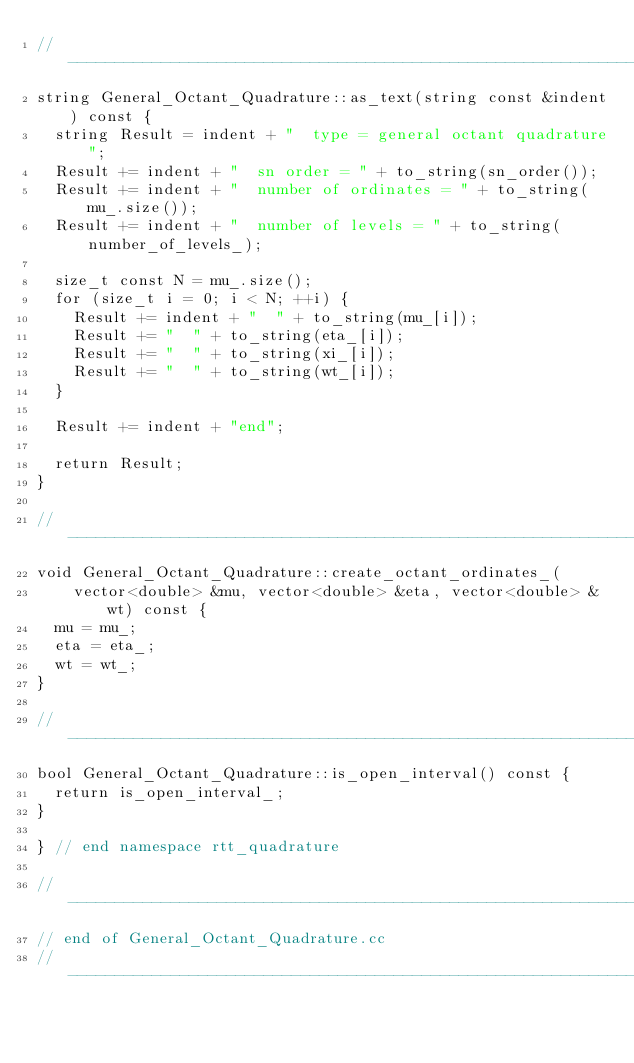Convert code to text. <code><loc_0><loc_0><loc_500><loc_500><_C++_>//---------------------------------------------------------------------------//
string General_Octant_Quadrature::as_text(string const &indent) const {
  string Result = indent + "  type = general octant quadrature";
  Result += indent + "  sn order = " + to_string(sn_order());
  Result += indent + "  number of ordinates = " + to_string(mu_.size());
  Result += indent + "  number of levels = " + to_string(number_of_levels_);

  size_t const N = mu_.size();
  for (size_t i = 0; i < N; ++i) {
    Result += indent + "  " + to_string(mu_[i]);
    Result += "  " + to_string(eta_[i]);
    Result += "  " + to_string(xi_[i]);
    Result += "  " + to_string(wt_[i]);
  }

  Result += indent + "end";

  return Result;
}

//---------------------------------------------------------------------------//
void General_Octant_Quadrature::create_octant_ordinates_(
    vector<double> &mu, vector<double> &eta, vector<double> &wt) const {
  mu = mu_;
  eta = eta_;
  wt = wt_;
}

//---------------------------------------------------------------------------//
bool General_Octant_Quadrature::is_open_interval() const {
  return is_open_interval_;
}

} // end namespace rtt_quadrature

//---------------------------------------------------------------------------//
// end of General_Octant_Quadrature.cc
//---------------------------------------------------------------------------//
</code> 